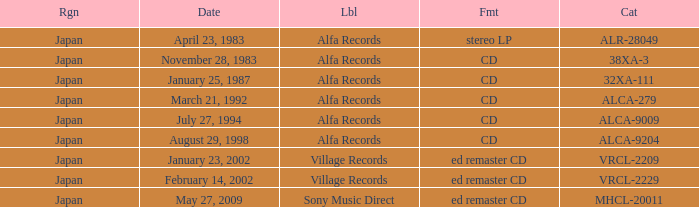What is the format of the date February 14, 2002? Ed remaster cd. 